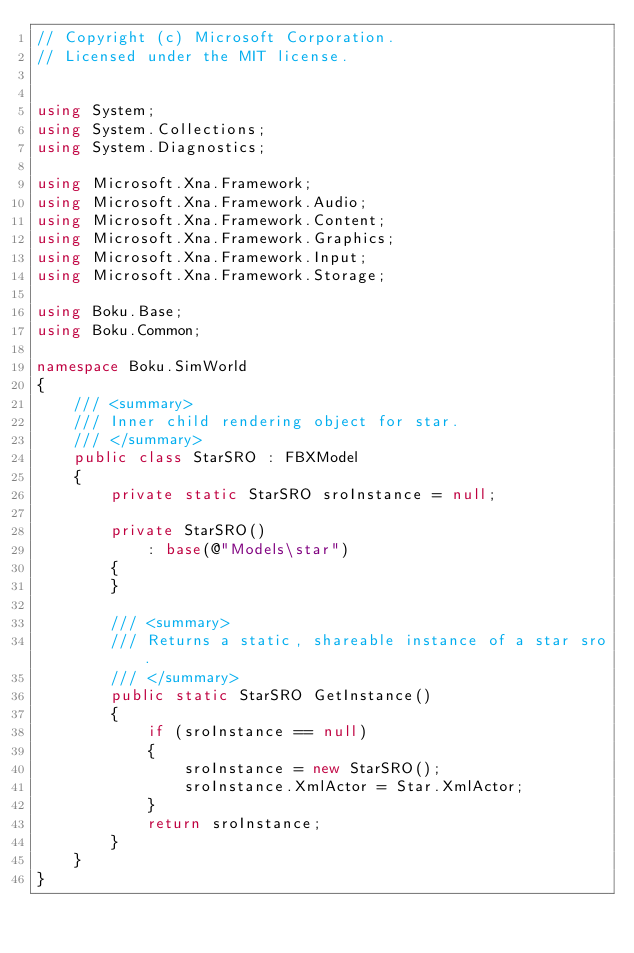<code> <loc_0><loc_0><loc_500><loc_500><_C#_>// Copyright (c) Microsoft Corporation.
// Licensed under the MIT license.


using System;
using System.Collections;
using System.Diagnostics;

using Microsoft.Xna.Framework;
using Microsoft.Xna.Framework.Audio;
using Microsoft.Xna.Framework.Content;
using Microsoft.Xna.Framework.Graphics;
using Microsoft.Xna.Framework.Input;
using Microsoft.Xna.Framework.Storage;

using Boku.Base;
using Boku.Common;

namespace Boku.SimWorld
{
    /// <summary>
    /// Inner child rendering object for star.
    /// </summary>
    public class StarSRO : FBXModel
    {
        private static StarSRO sroInstance = null;

        private StarSRO()
            : base(@"Models\star")
        {
        }

        /// <summary>
        /// Returns a static, shareable instance of a star sro.
        /// </summary>
        public static StarSRO GetInstance()
        {
            if (sroInstance == null)
            {
                sroInstance = new StarSRO();
                sroInstance.XmlActor = Star.XmlActor;
            }
            return sroInstance;
        }
    } 
}
</code> 